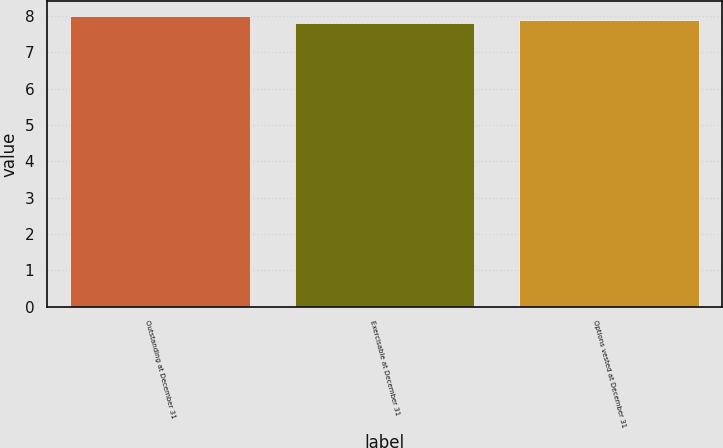Convert chart. <chart><loc_0><loc_0><loc_500><loc_500><bar_chart><fcel>Outstanding at December 31<fcel>Exercisable at December 31<fcel>Options vested at December 31<nl><fcel>8<fcel>7.8<fcel>7.9<nl></chart> 